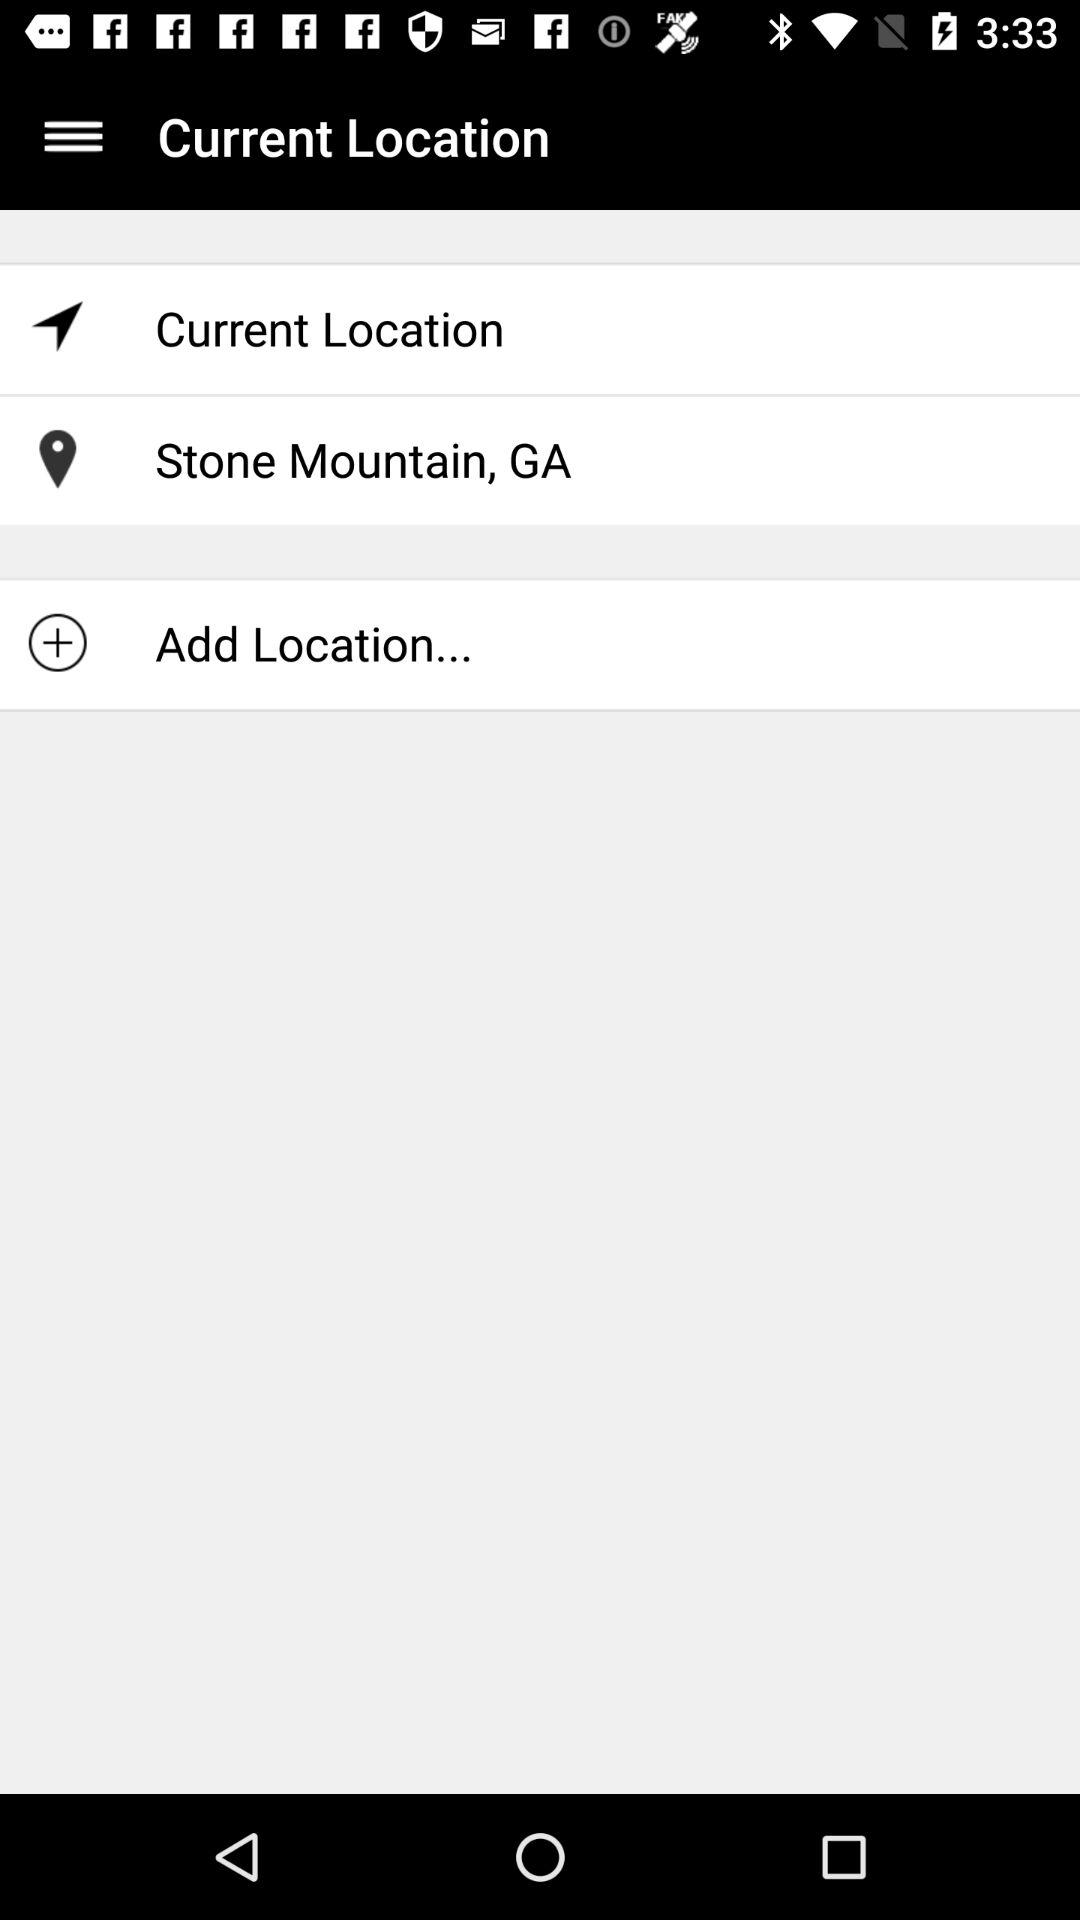What is the mentioned location? The location is Stone Mountain, GA. 